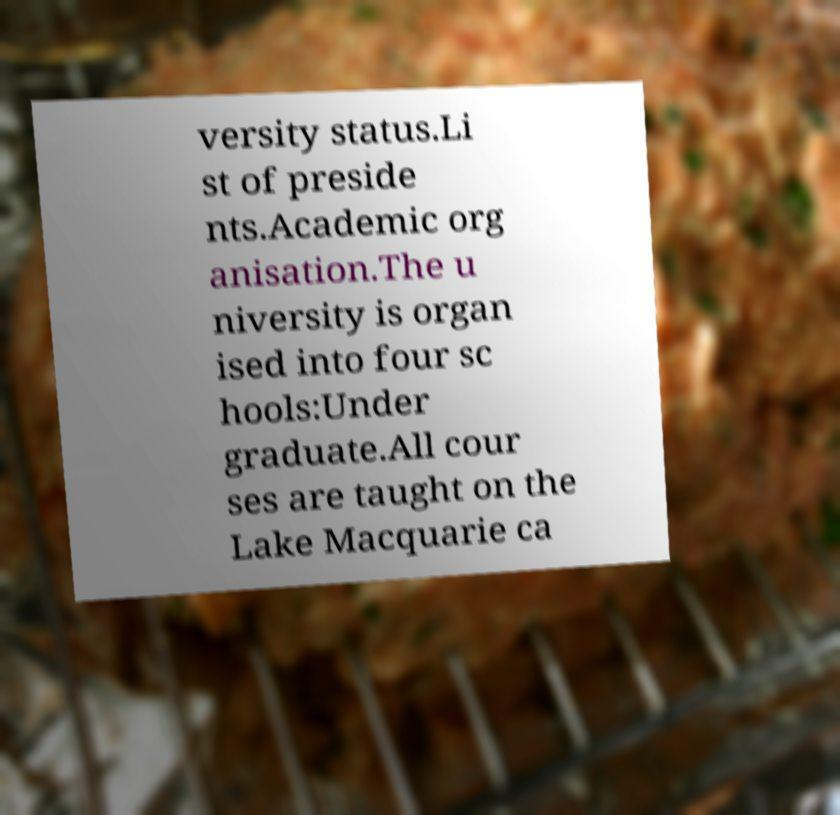Can you read and provide the text displayed in the image?This photo seems to have some interesting text. Can you extract and type it out for me? versity status.Li st of preside nts.Academic org anisation.The u niversity is organ ised into four sc hools:Under graduate.All cour ses are taught on the Lake Macquarie ca 